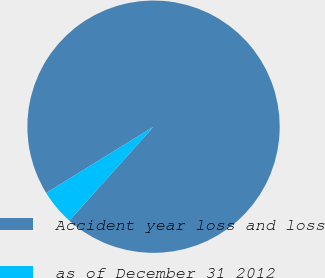Convert chart. <chart><loc_0><loc_0><loc_500><loc_500><pie_chart><fcel>Accident year loss and loss<fcel>as of December 31 2012<nl><fcel>95.43%<fcel>4.57%<nl></chart> 